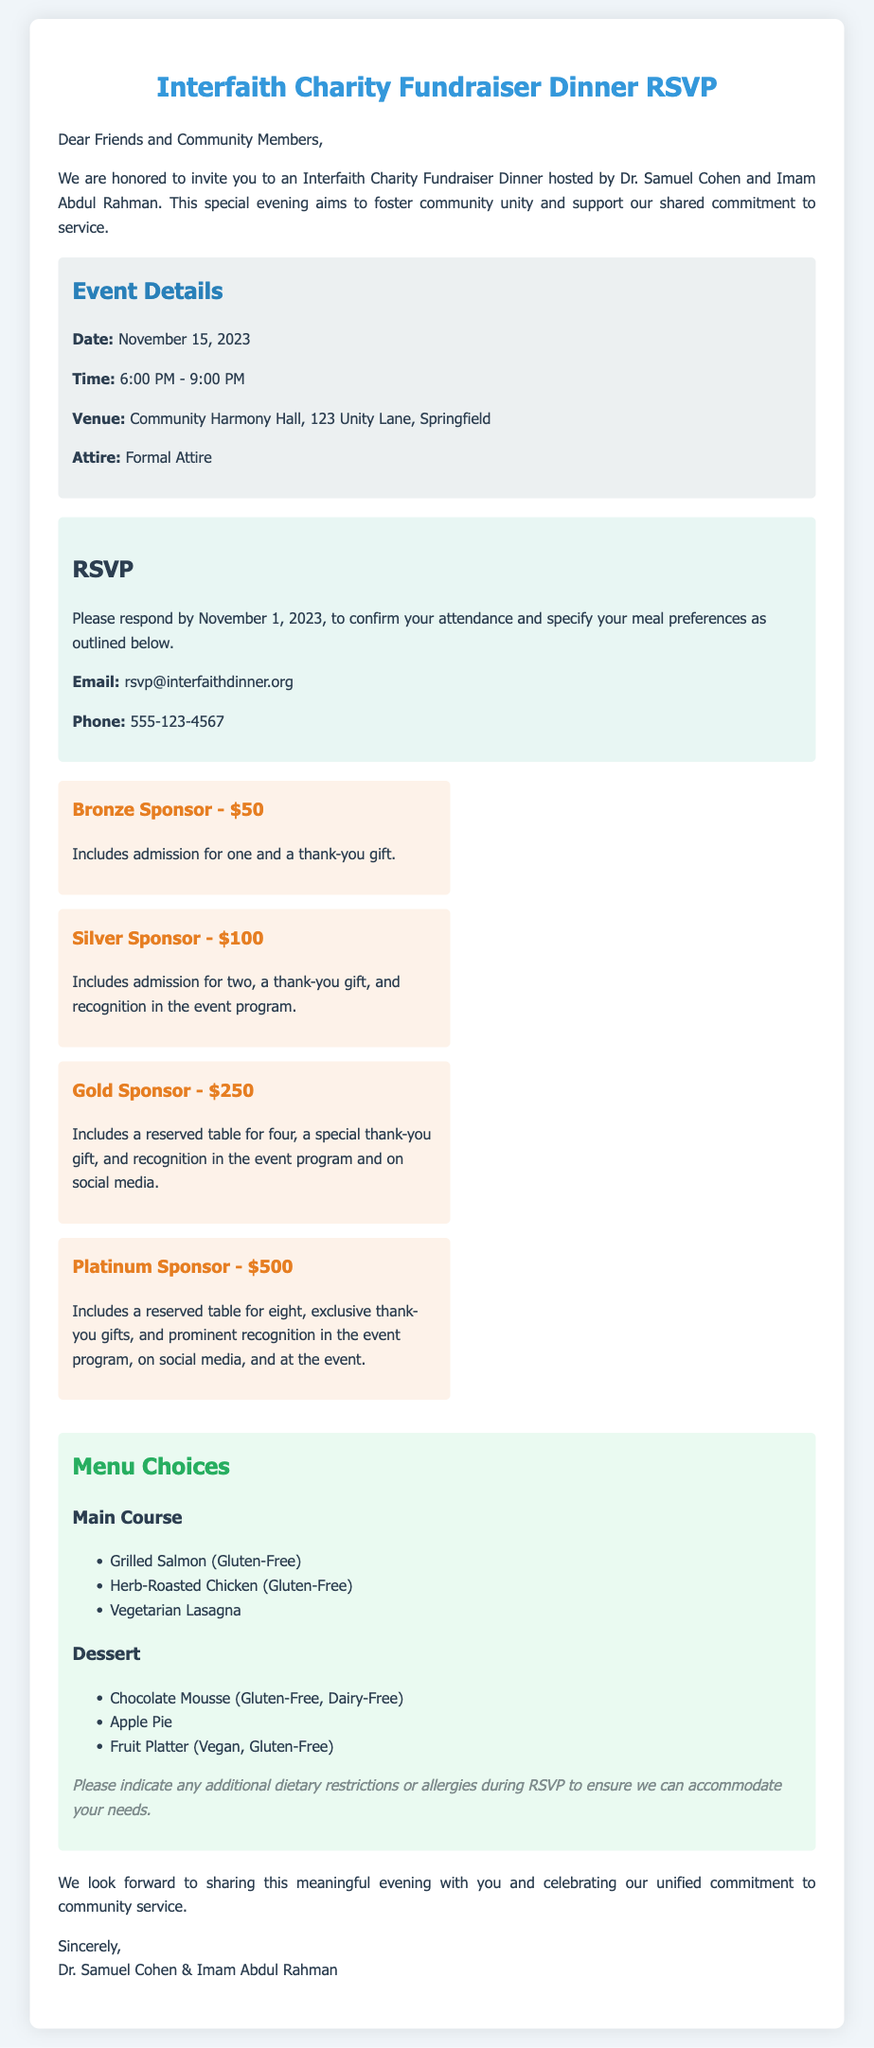What is the date of the event? The date of the event is clearly stated in the document under the event details section.
Answer: November 15, 2023 How long is the event scheduled to last? The event start time is at 6:00 PM and ends at 9:00 PM, so we can calculate the duration.
Answer: 3 hours Who are the hosts of the dinner? The hosts of the dinner are mentioned in the introductory paragraph.
Answer: Dr. Samuel Cohen and Imam Abdul Rahman What is the highest donation tier? The highest donation tier is listed among the donation tiers in the document.
Answer: Platinum Sponsor - $500 What is one option available for dessert? Dessert options are included in the menu choices section, listing several items.
Answer: Chocolate Mousse What should guests indicate during the RSVP? The RSVP section advises what additional information to provide when responding.
Answer: Dietary restrictions or allergies What time does the dinner start? The event details clearly specify the start time of the dinner.
Answer: 6:00 PM What is included in the Gold Sponsor tier? The Gold Sponsor tier is described in the donation tiers section, listing the benefits included.
Answer: Reserved table for four, special thank-you gift, and recognition in the event program and on social media 